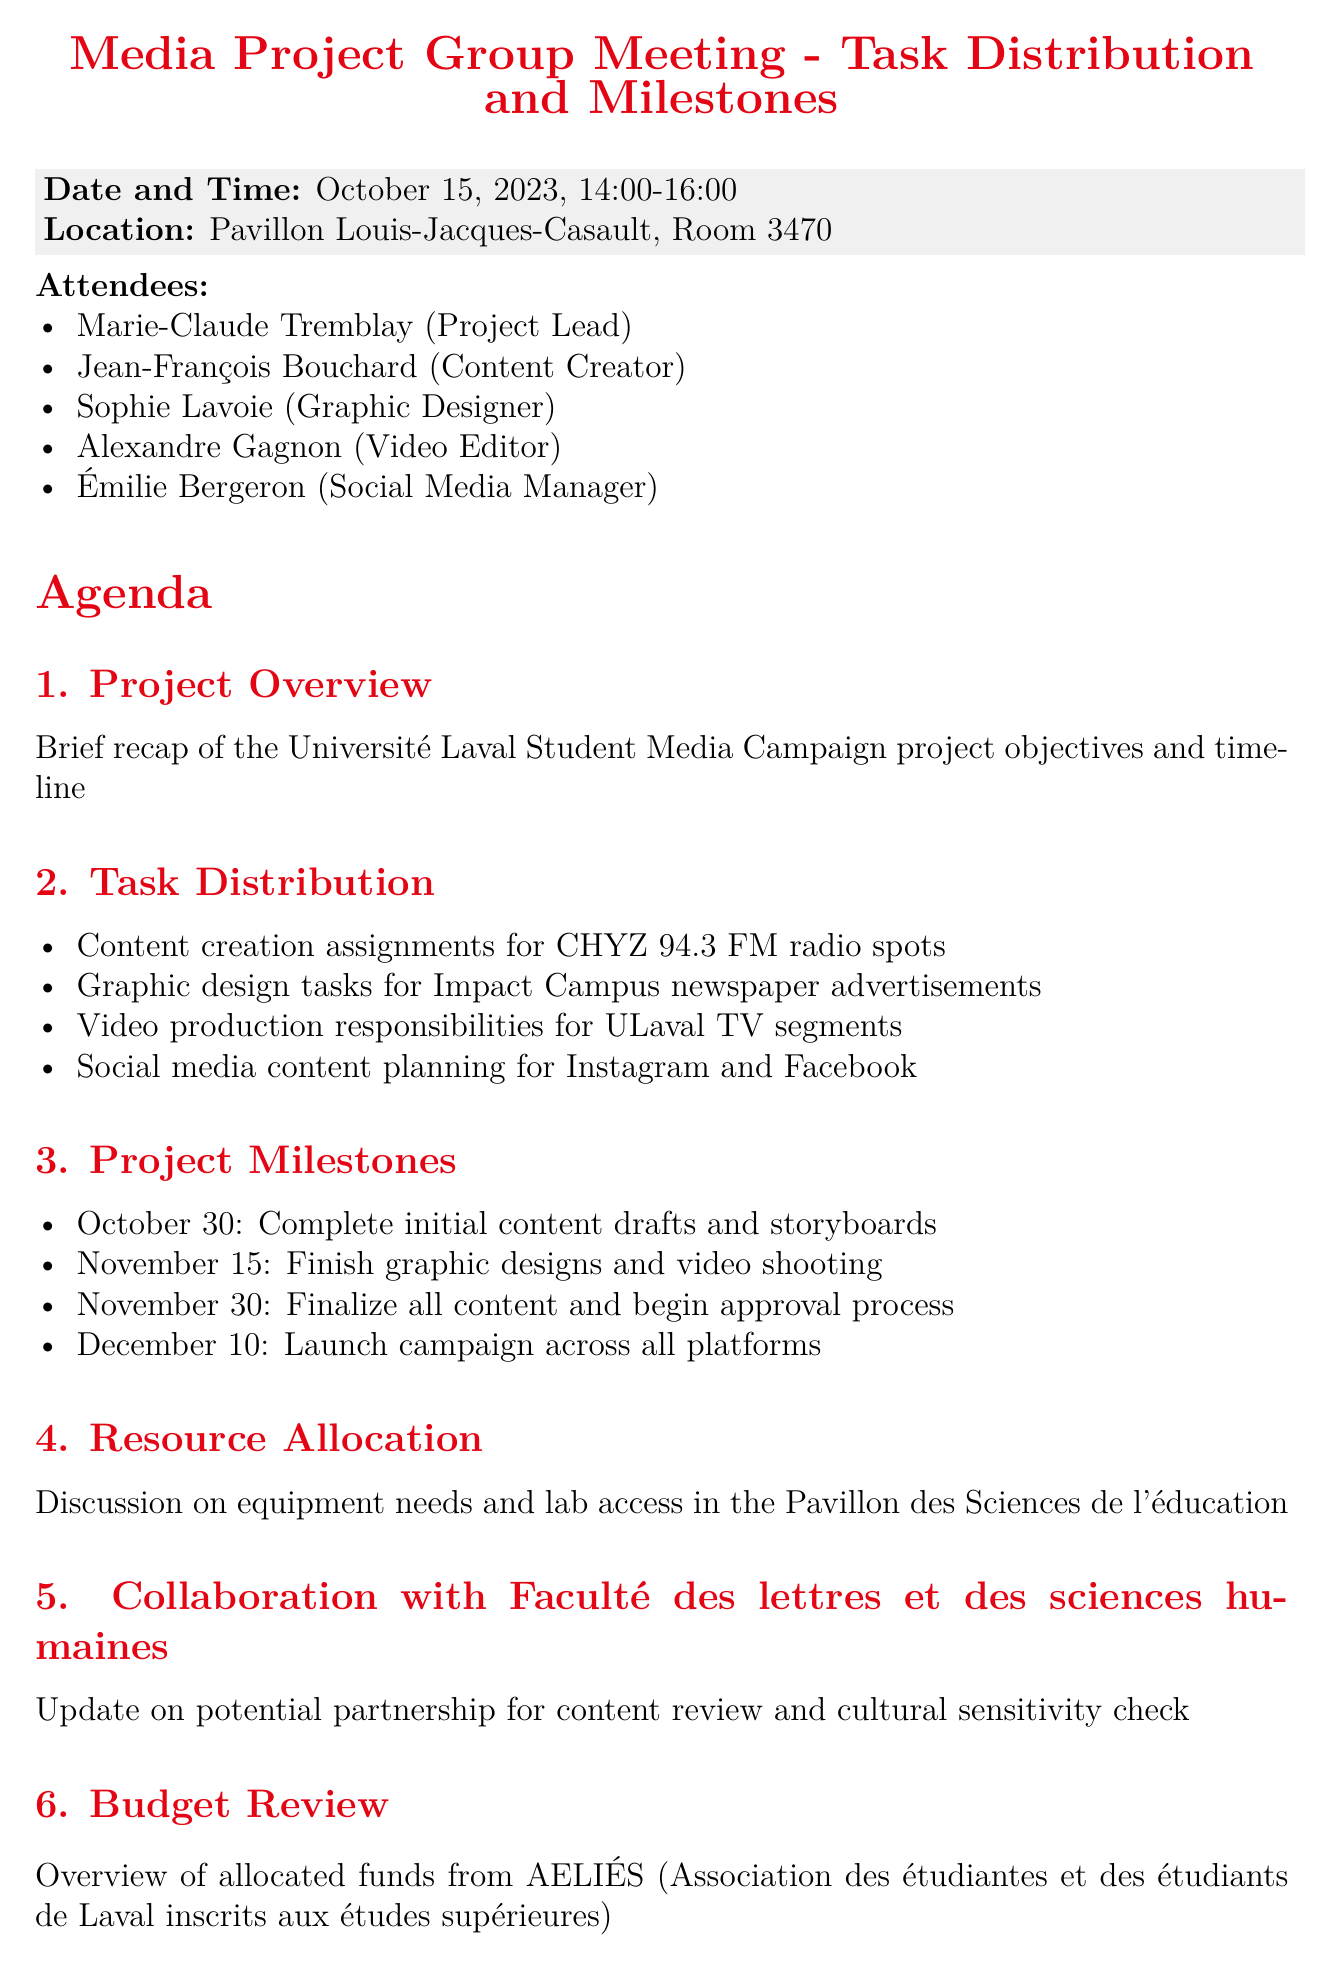What is the date and time of the meeting? The date and time is mentioned in the document as "October 15, 2023, 14:00-16:00".
Answer: October 15, 2023, 14:00-16:00 Who is the Project Lead? The document lists the attendees and identifies Marie-Claude Tremblay as the Project Lead.
Answer: Marie-Claude Tremblay What is one task assigned to Jean-François? The document states that Jean-François has the action item to reach out to Prof. Martine Paquin for guidance on radio content.
Answer: Reach out to Prof. Martine Paquin What is the first project milestone date? The milestones section specifies that the first date is October 30 for completing initial content drafts and storyboards.
Answer: October 30 Which room will the meeting take place in? The location section indicates that the meeting will be held in Room 3470.
Answer: Room 3470 What is one of the resource allocation topics discussed? The document mentions a discussion on equipment needs and lab access in the Pavillon des Sciences de l'éducation as a resource allocation topic.
Answer: Equipment needs and lab access What are the shared platforms mentioned for coordination? The next steps mention setting up a shared project management board on Microsoft Teams for coordination.
Answer: Microsoft Teams How many action items are listed in the document? The action items section includes a total of five action items for team members to follow up on.
Answer: Five 